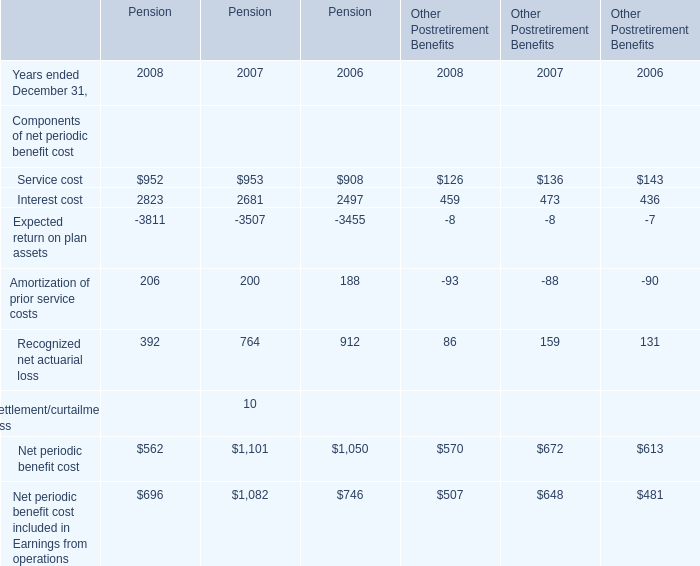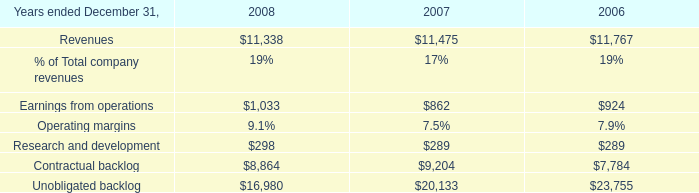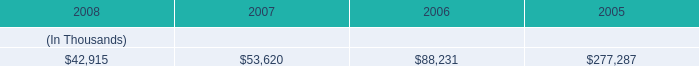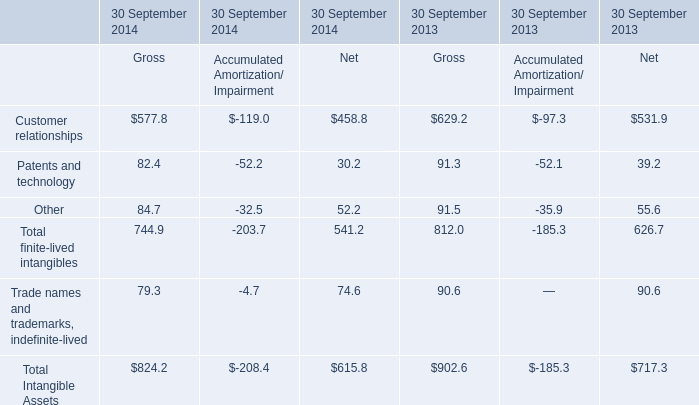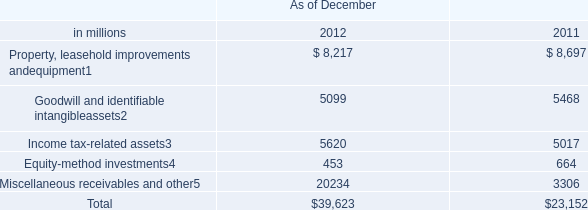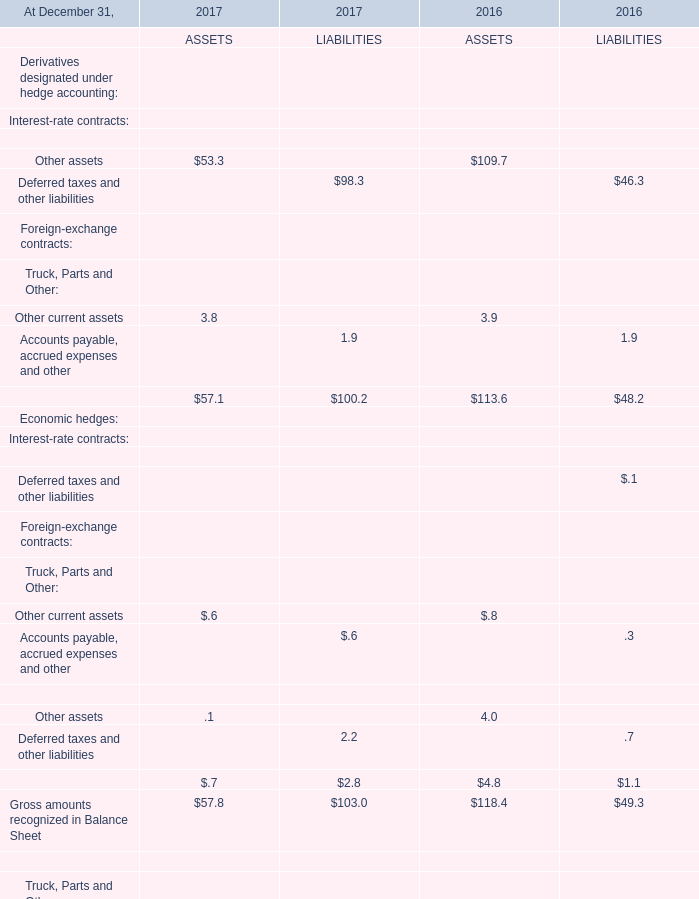Which year is Gross amounts recognized in Balance Sheet for LIABILITIES higher? 
Answer: 2017. 